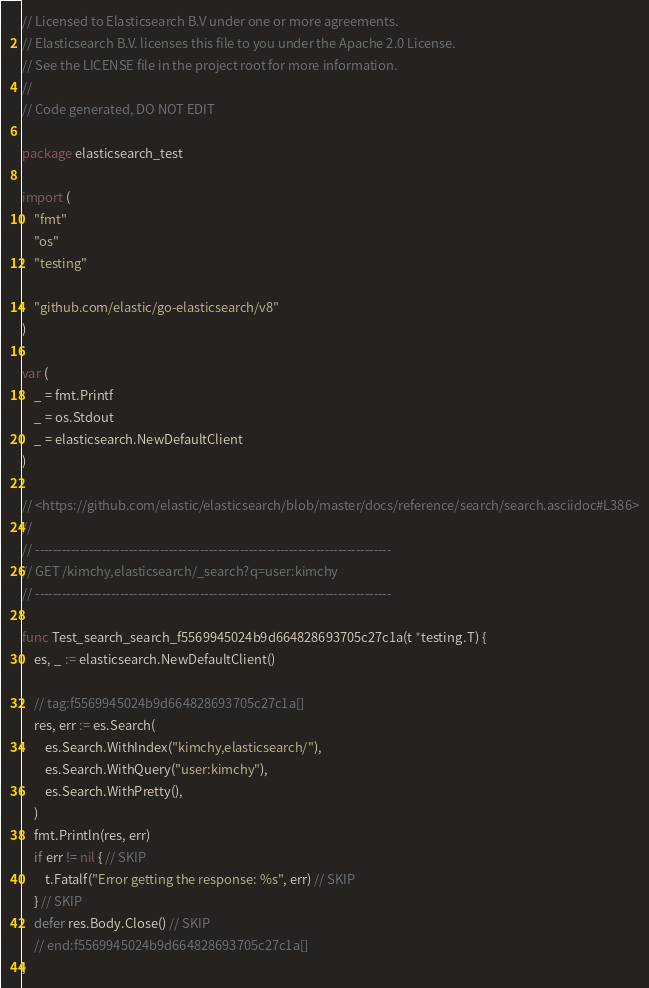<code> <loc_0><loc_0><loc_500><loc_500><_Go_>// Licensed to Elasticsearch B.V under one or more agreements.
// Elasticsearch B.V. licenses this file to you under the Apache 2.0 License.
// See the LICENSE file in the project root for more information.
//
// Code generated, DO NOT EDIT

package elasticsearch_test

import (
	"fmt"
	"os"
	"testing"

	"github.com/elastic/go-elasticsearch/v8"
)

var (
	_ = fmt.Printf
	_ = os.Stdout
	_ = elasticsearch.NewDefaultClient
)

// <https://github.com/elastic/elasticsearch/blob/master/docs/reference/search/search.asciidoc#L386>
//
// --------------------------------------------------------------------------------
// GET /kimchy,elasticsearch/_search?q=user:kimchy
// --------------------------------------------------------------------------------

func Test_search_search_f5569945024b9d664828693705c27c1a(t *testing.T) {
	es, _ := elasticsearch.NewDefaultClient()

	// tag:f5569945024b9d664828693705c27c1a[]
	res, err := es.Search(
		es.Search.WithIndex("kimchy,elasticsearch/"),
		es.Search.WithQuery("user:kimchy"),
		es.Search.WithPretty(),
	)
	fmt.Println(res, err)
	if err != nil { // SKIP
		t.Fatalf("Error getting the response: %s", err) // SKIP
	} // SKIP
	defer res.Body.Close() // SKIP
	// end:f5569945024b9d664828693705c27c1a[]
}
</code> 